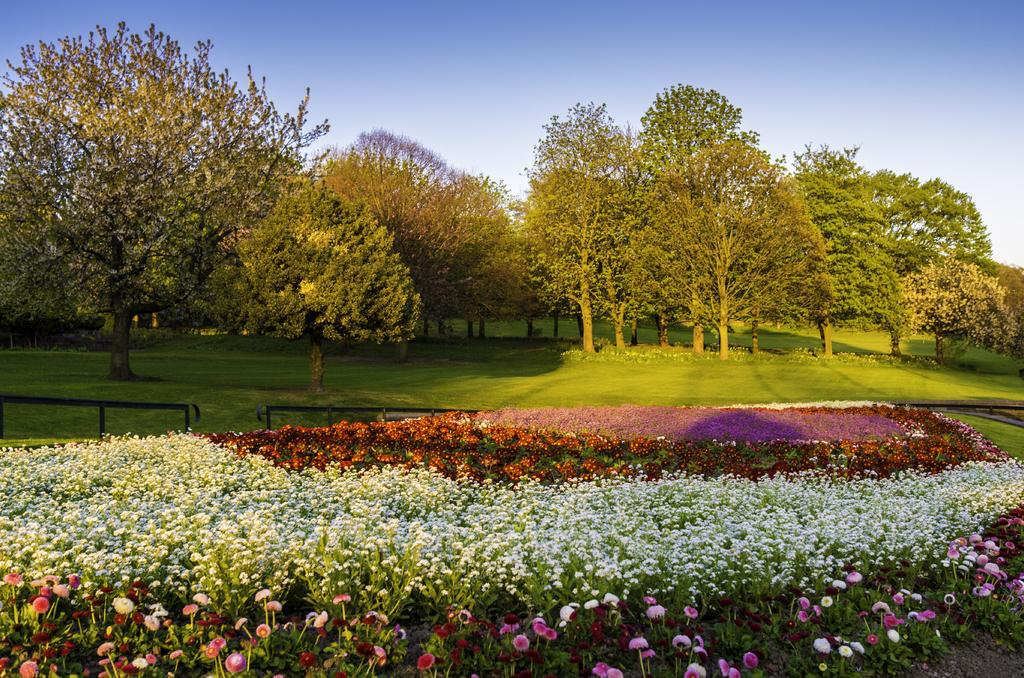What type of plants can be seen in the image? There are colorful flowers in the image. What type of structure is visible in the image? There is fencing visible in the image. What type of vegetation is present in the image? Grass is present in the image. What other natural elements can be seen in the image? There are trees in the image. What is visible in the background of the image? The sky is visible in the image. What type of banana is being used as a pot for the flowers in the image? There is no banana present in the image, nor is it being used as a pot for the flowers. 